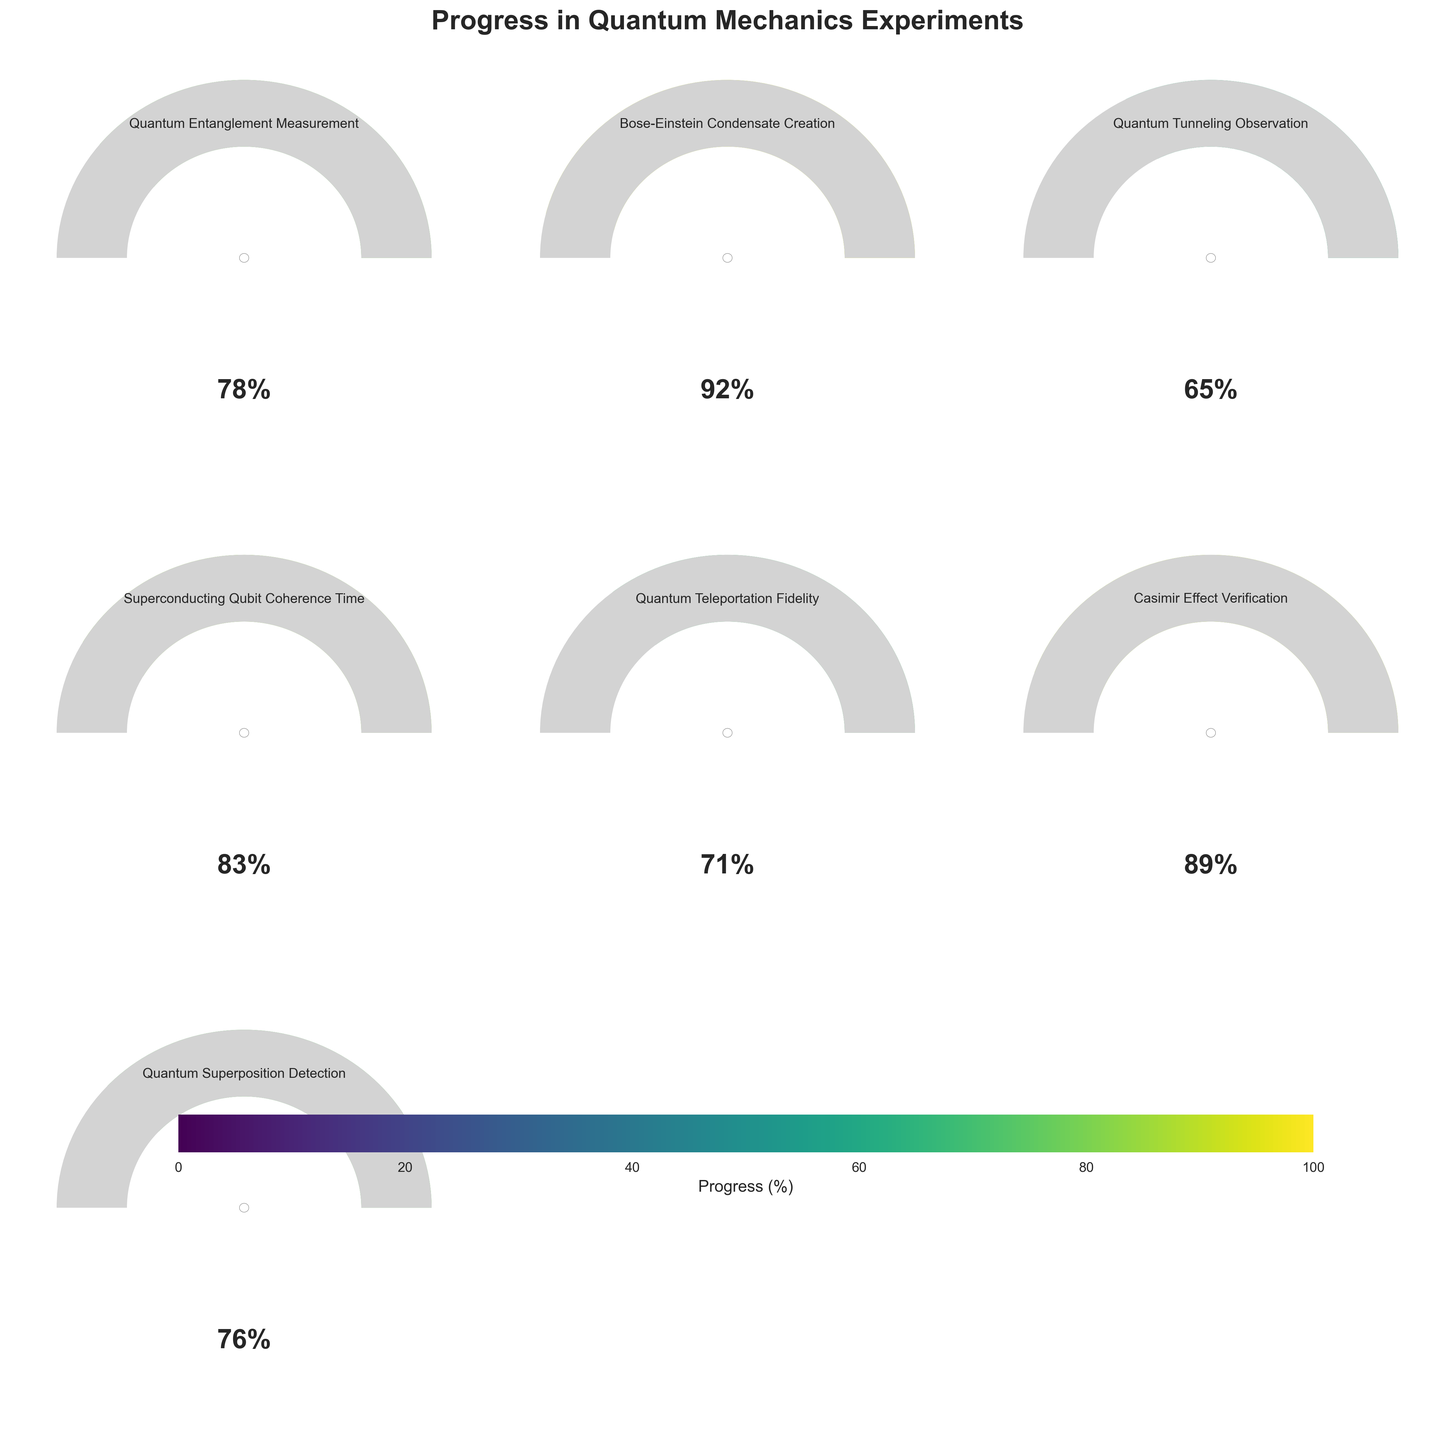Which experiment shows the highest progress? The experiment with the highest progress can be identified by looking for the gauge that is most filled towards the right. Based on the figure, the Bose-Einstein Condensate Creation has a progress of 92%, which is the highest among all experiments.
Answer: Bose-Einstein Condensate Creation Which experiment shows the lowest progress? The experiment with the lowest progress can be identified by looking for the gauge that is least filled. Based on the figure, the Quantum Tunneling Observation has a progress of 65%, which is the lowest among all experiments.
Answer: Quantum Tunneling Observation What is the average progress of all experiments? To calculate the average progress, sum all the progress values and then divide by the total number of experiments. The progress values are: 78, 92, 65, 83, 71, 89, and 76. The sum is 554, and the number of experiments is 7. Thus, the average progress is 554/7 ≈ 79.14.
Answer: 79.14% How many experiments have a progress of more than 80%? To determine the number of experiments with progress greater than 80%, count the gauges with progress values above 80. The experiments are: Bose-Einstein Condensate Creation (92%), Superconducting Qubit Coherence Time (83%), and Casimir Effect Verification (89%). There are 3 such experiments.
Answer: 3 How much more progress is needed for the Quantum Teleportation Fidelity experiment to reach its goal? The Quantum Teleportation Fidelity experiment has a progress of 71%. To reach 100%, it needs 100 - 71 = 29% more progress.
Answer: 29% Which experiment's progress is closest to 75%? Look for the gauge that displays a progress closest to 75%. Based on the figure, the Quantum Superposition Detection has a progress of 76%, which is closest to 75%.
Answer: Quantum Superposition Detection What is the range of progress values among all experiments? The range is determined by subtracting the smallest progress value from the largest progress value. The highest progress is 92% (Bose-Einstein Condensate Creation) and the lowest is 65% (Quantum Tunneling Observation). The range is 92 - 65 = 27%.
Answer: 27% Which experiments have a progress between 70% and 80% inclusive? Identify the experiments whose progress falls within the range 70% to 80%. The relevant experiments are: Quantum Entanglement Measurement (78%), Quantum Teleportation Fidelity (71%), and Quantum Superposition Detection (76%).
Answer: Quantum Entanglement Measurement, Quantum Teleportation Fidelity, Quantum Superposition Detection If we combine the progress of Quantum Entanglement Measurement and Casimir Effect Verification, what is the total progress? The combined progress is found by summing the progress percentages of both experiments. Quantum Entanglement Measurement is 78% and Casimir Effect Verification is 89%. The total is 78% + 89% = 167%.
Answer: 167% Which experiment shows the second highest progress? To find the second highest progress, first identify the highest (Bose-Einstein Condensate Creation at 92%) and then look for the next highest value. The second highest is Casimir Effect Verification with 89%.
Answer: Casimir Effect Verification 